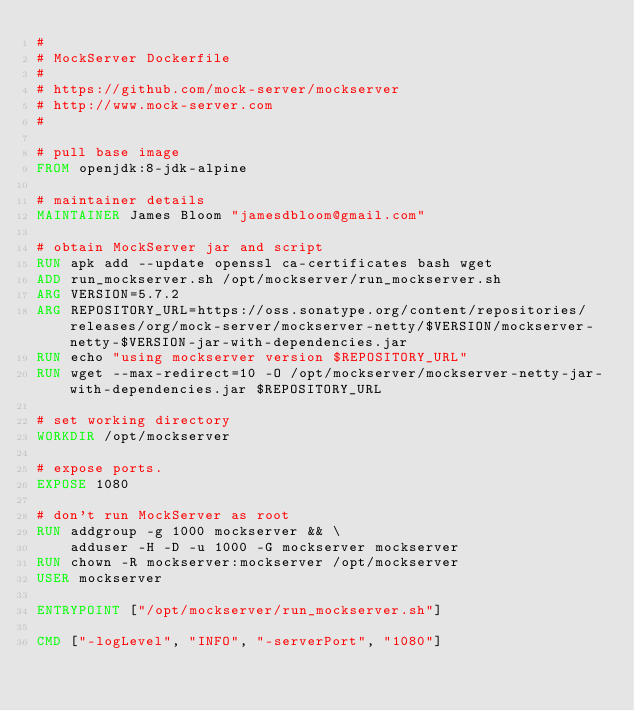Convert code to text. <code><loc_0><loc_0><loc_500><loc_500><_Dockerfile_>#
# MockServer Dockerfile
#
# https://github.com/mock-server/mockserver
# http://www.mock-server.com
#

# pull base image
FROM openjdk:8-jdk-alpine

# maintainer details
MAINTAINER James Bloom "jamesdbloom@gmail.com"

# obtain MockServer jar and script
RUN apk add --update openssl ca-certificates bash wget
ADD run_mockserver.sh /opt/mockserver/run_mockserver.sh
ARG VERSION=5.7.2
ARG REPOSITORY_URL=https://oss.sonatype.org/content/repositories/releases/org/mock-server/mockserver-netty/$VERSION/mockserver-netty-$VERSION-jar-with-dependencies.jar
RUN echo "using mockserver version $REPOSITORY_URL"
RUN wget --max-redirect=10 -O /opt/mockserver/mockserver-netty-jar-with-dependencies.jar $REPOSITORY_URL

# set working directory
WORKDIR /opt/mockserver

# expose ports.
EXPOSE 1080

# don't run MockServer as root
RUN addgroup -g 1000 mockserver && \
    adduser -H -D -u 1000 -G mockserver mockserver
RUN chown -R mockserver:mockserver /opt/mockserver
USER mockserver

ENTRYPOINT ["/opt/mockserver/run_mockserver.sh"]

CMD ["-logLevel", "INFO", "-serverPort", "1080"]
</code> 